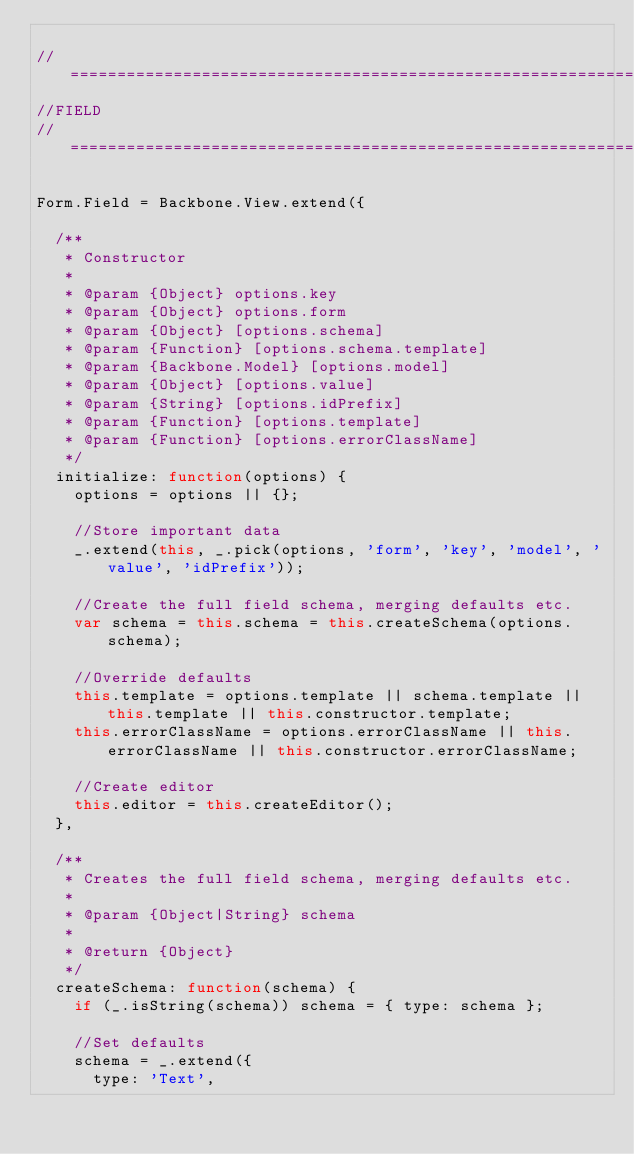<code> <loc_0><loc_0><loc_500><loc_500><_JavaScript_>
//==================================================================================================
//FIELD
//==================================================================================================

Form.Field = Backbone.View.extend({

  /**
   * Constructor
   * 
   * @param {Object} options.key
   * @param {Object} options.form
   * @param {Object} [options.schema]
   * @param {Function} [options.schema.template]
   * @param {Backbone.Model} [options.model]
   * @param {Object} [options.value]
   * @param {String} [options.idPrefix]
   * @param {Function} [options.template]
   * @param {Function} [options.errorClassName]
   */
  initialize: function(options) {
    options = options || {};

    //Store important data
    _.extend(this, _.pick(options, 'form', 'key', 'model', 'value', 'idPrefix'));

    //Create the full field schema, merging defaults etc.
    var schema = this.schema = this.createSchema(options.schema);

    //Override defaults
    this.template = options.template || schema.template || this.template || this.constructor.template;
    this.errorClassName = options.errorClassName || this.errorClassName || this.constructor.errorClassName;

    //Create editor
    this.editor = this.createEditor();
  },

  /**
   * Creates the full field schema, merging defaults etc.
   *
   * @param {Object|String} schema
   *
   * @return {Object}
   */
  createSchema: function(schema) {
    if (_.isString(schema)) schema = { type: schema };

    //Set defaults
    schema = _.extend({
      type: 'Text',</code> 